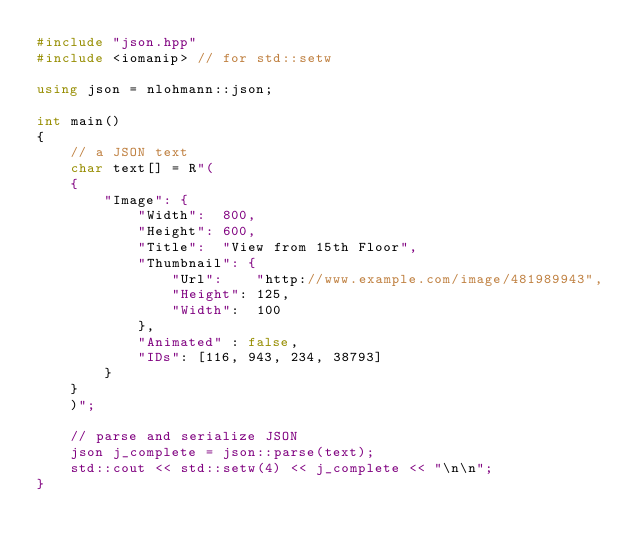Convert code to text. <code><loc_0><loc_0><loc_500><loc_500><_C++_>#include "json.hpp"
#include <iomanip> // for std::setw

using json = nlohmann::json;

int main()
{
    // a JSON text
    char text[] = R"(
    {
        "Image": {
            "Width":  800,
            "Height": 600,
            "Title":  "View from 15th Floor",
            "Thumbnail": {
                "Url":    "http://www.example.com/image/481989943",
                "Height": 125,
                "Width":  100
            },
            "Animated" : false,
            "IDs": [116, 943, 234, 38793]
        }
    }
    )";

    // parse and serialize JSON
    json j_complete = json::parse(text);
    std::cout << std::setw(4) << j_complete << "\n\n";
}
</code> 